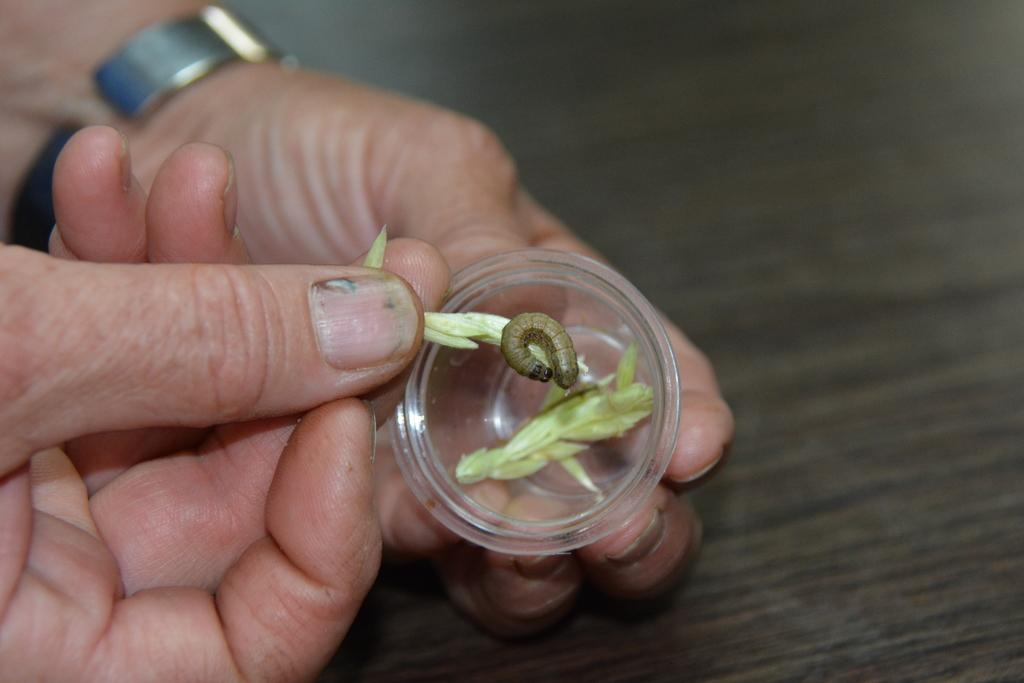What is the person holding in the image? The person is holding a cup in the image. What else can be seen in the image besides the cup? There are hands visible, flower petals, and a caterpillar present in the image. How would you describe the background of the image? The background of the image is blurry. What type of discovery is the person making in the image? There is no indication of a discovery being made in the image. 